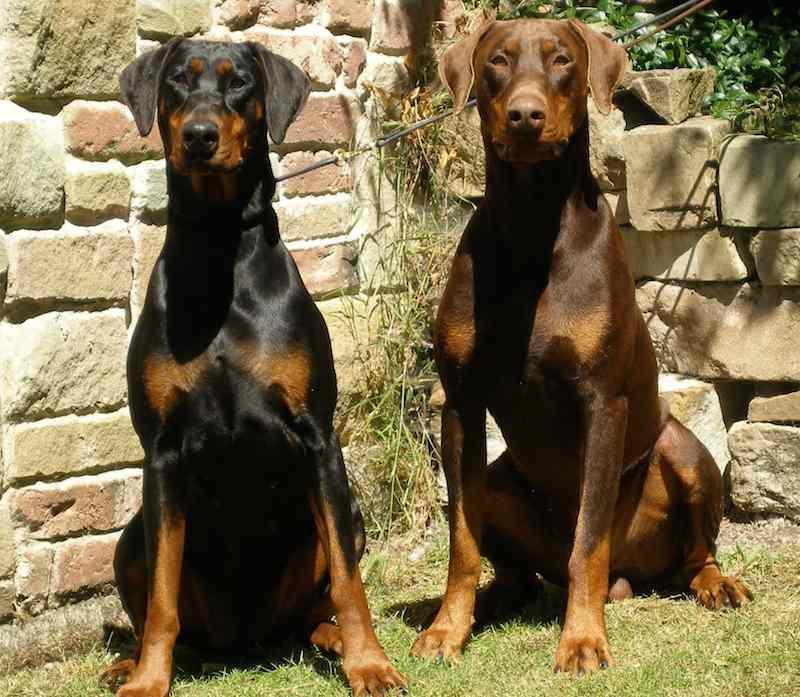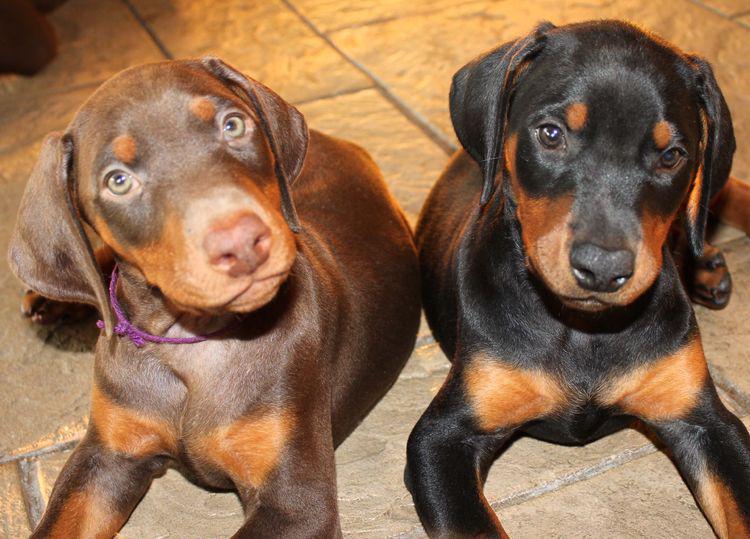The first image is the image on the left, the second image is the image on the right. Assess this claim about the two images: "Each image contains a pair of animals, but one image features puppies and the other features adult dogs.". Correct or not? Answer yes or no. Yes. 